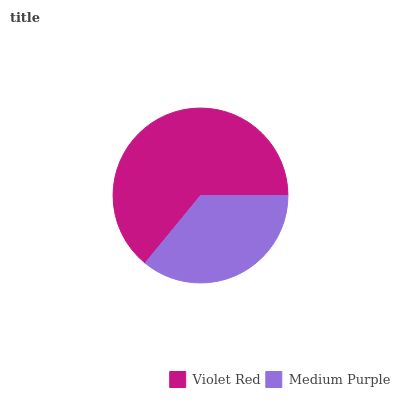Is Medium Purple the minimum?
Answer yes or no. Yes. Is Violet Red the maximum?
Answer yes or no. Yes. Is Medium Purple the maximum?
Answer yes or no. No. Is Violet Red greater than Medium Purple?
Answer yes or no. Yes. Is Medium Purple less than Violet Red?
Answer yes or no. Yes. Is Medium Purple greater than Violet Red?
Answer yes or no. No. Is Violet Red less than Medium Purple?
Answer yes or no. No. Is Violet Red the high median?
Answer yes or no. Yes. Is Medium Purple the low median?
Answer yes or no. Yes. Is Medium Purple the high median?
Answer yes or no. No. Is Violet Red the low median?
Answer yes or no. No. 